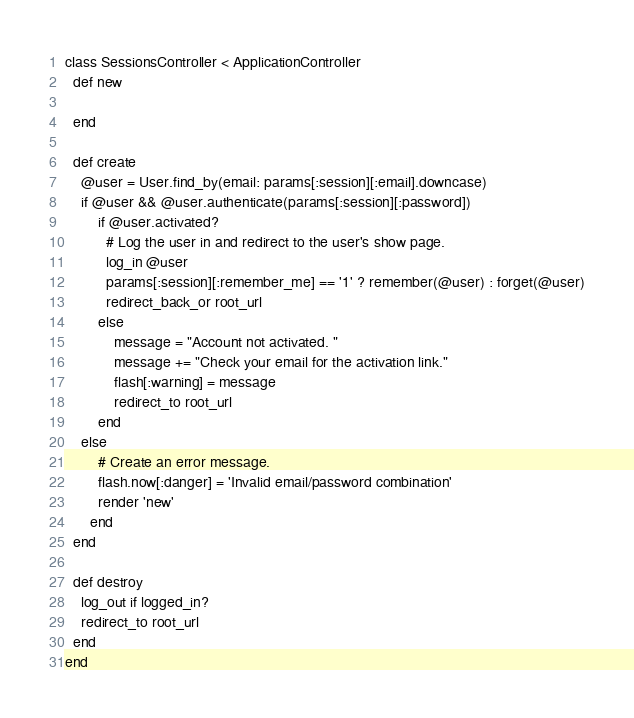<code> <loc_0><loc_0><loc_500><loc_500><_Ruby_>class SessionsController < ApplicationController
  def new
  	
  end

  def create
  	@user = User.find_by(email: params[:session][:email].downcase)
  	if @user && @user.authenticate(params[:session][:password])
  		if @user.activated?
  		  # Log the user in and redirect to the user's show page.
  		  log_in @user
  		  params[:session][:remember_me] == '1' ? remember(@user) : forget(@user)
  		  redirect_back_or root_url
  		else
  			message = "Account not activated. "
  			message += "Check your email for the activation link."
  			flash[:warning] = message
  			redirect_to root_url
  		end
  	else
  		# Create an error message.
  		flash.now[:danger] = 'Invalid email/password combination'
	  	render 'new'
	  end
  end

  def destroy
  	log_out if logged_in?
  	redirect_to root_url
  end
end
</code> 